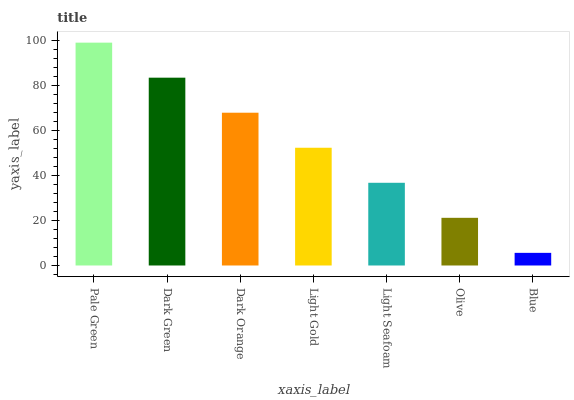Is Blue the minimum?
Answer yes or no. Yes. Is Pale Green the maximum?
Answer yes or no. Yes. Is Dark Green the minimum?
Answer yes or no. No. Is Dark Green the maximum?
Answer yes or no. No. Is Pale Green greater than Dark Green?
Answer yes or no. Yes. Is Dark Green less than Pale Green?
Answer yes or no. Yes. Is Dark Green greater than Pale Green?
Answer yes or no. No. Is Pale Green less than Dark Green?
Answer yes or no. No. Is Light Gold the high median?
Answer yes or no. Yes. Is Light Gold the low median?
Answer yes or no. Yes. Is Olive the high median?
Answer yes or no. No. Is Olive the low median?
Answer yes or no. No. 